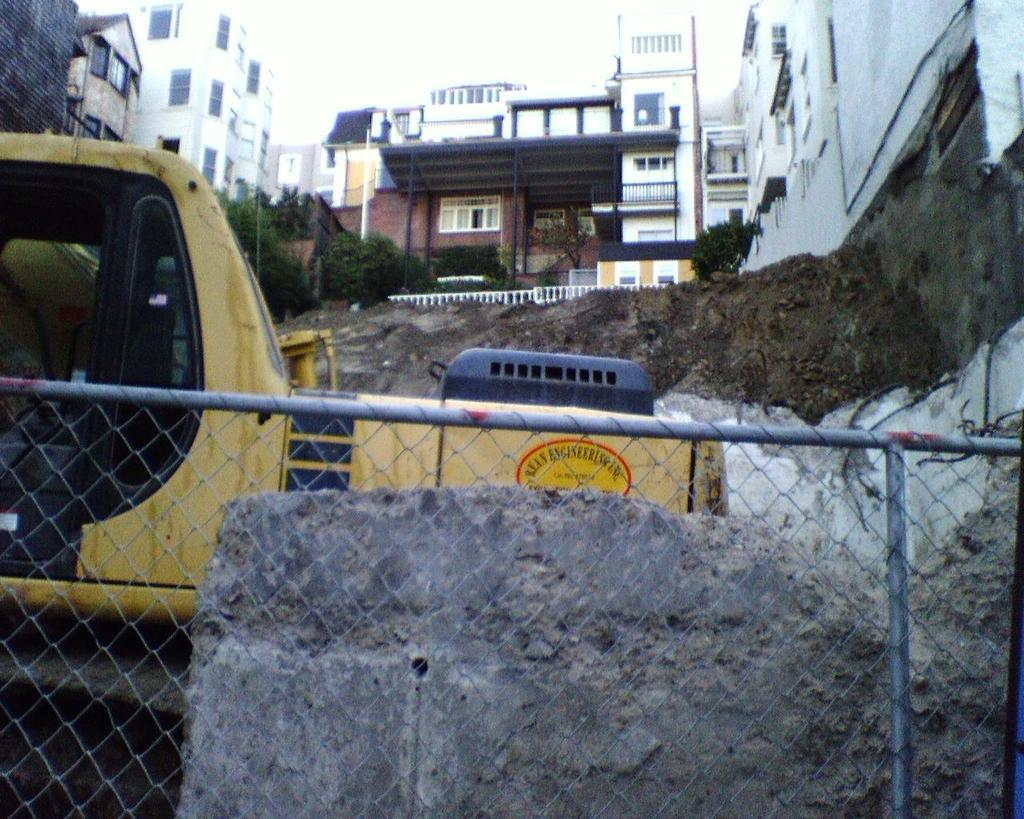What type of barrier is present at the bottom of the image? There is a net fencing at the bottom of the image. What other object can be seen at the bottom of the image? There is a rock at the bottom of the image. What can be seen on the left side of the image? There is a yellow color vehicle on the left side of the image. What structures are visible at the top of the image? There are buildings visible at the top of the image. What type of vegetation is visible at the top of the image? There are trees visible at the top of the image. Where is the oven located in the image? There is no oven present in the image. How many boys are visible in the image? There is no mention of boys in the image, so we cannot determine their presence or number. 